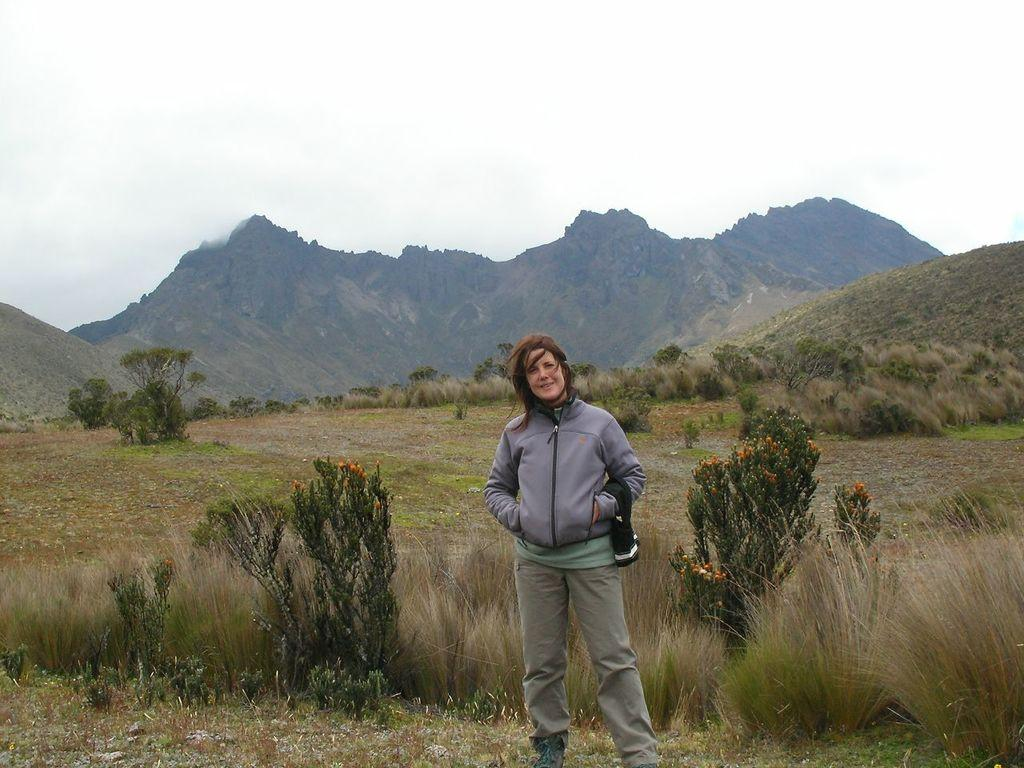What is the main subject in the center of the image? There is a person standing in the center of the image. What type of vegetation can be seen in the image? There are plants and grass in the image. What can be seen in the background of the image? There are mountains, additional plants, and trees in the background of the image. What is visible at the top of the image? The sky is visible at the top of the image. What type of liquid is being poured by the person in the image? There is no liquid being poured in the image; the person is simply standing in the center. 